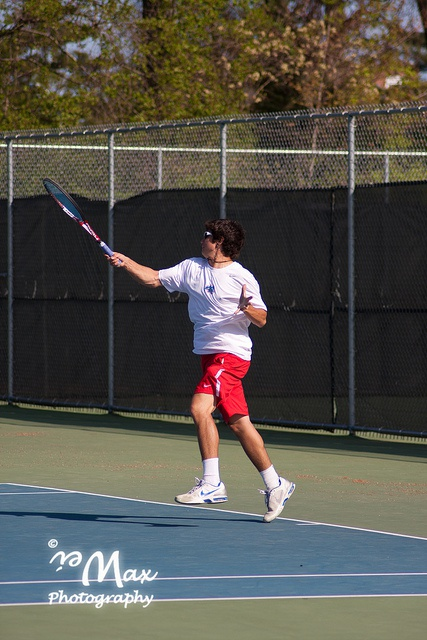Describe the objects in this image and their specific colors. I can see people in gray, lavender, black, and tan tones and tennis racket in gray, blue, black, and navy tones in this image. 